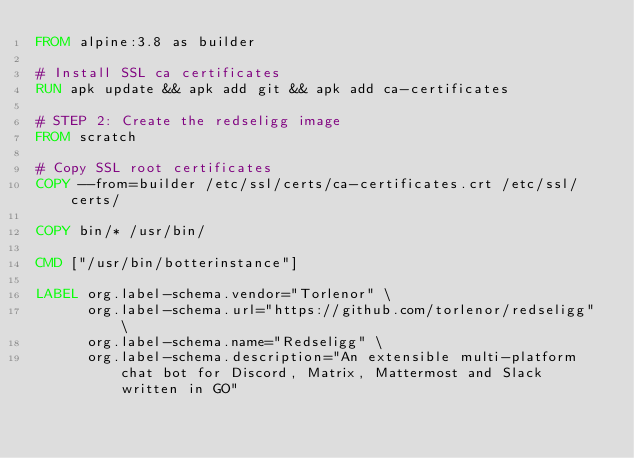Convert code to text. <code><loc_0><loc_0><loc_500><loc_500><_Dockerfile_>FROM alpine:3.8 as builder

# Install SSL ca certificates
RUN apk update && apk add git && apk add ca-certificates

# STEP 2: Create the redseligg image
FROM scratch

# Copy SSL root certificates
COPY --from=builder /etc/ssl/certs/ca-certificates.crt /etc/ssl/certs/

COPY bin/* /usr/bin/

CMD ["/usr/bin/botterinstance"]

LABEL org.label-schema.vendor="Torlenor" \
      org.label-schema.url="https://github.com/torlenor/redseligg" \
      org.label-schema.name="Redseligg" \
      org.label-schema.description="An extensible multi-platform chat bot for Discord, Matrix, Mattermost and Slack written in GO"

</code> 